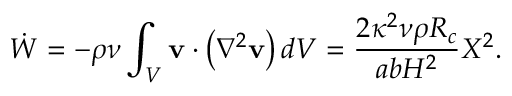Convert formula to latex. <formula><loc_0><loc_0><loc_500><loc_500>\dot { W } = - \rho \nu \int _ { V } v \cdot \left ( \nabla ^ { 2 } v \right ) d V = \frac { 2 \kappa ^ { 2 } \nu \rho R _ { c } } { a b H ^ { 2 } } X ^ { 2 } .</formula> 